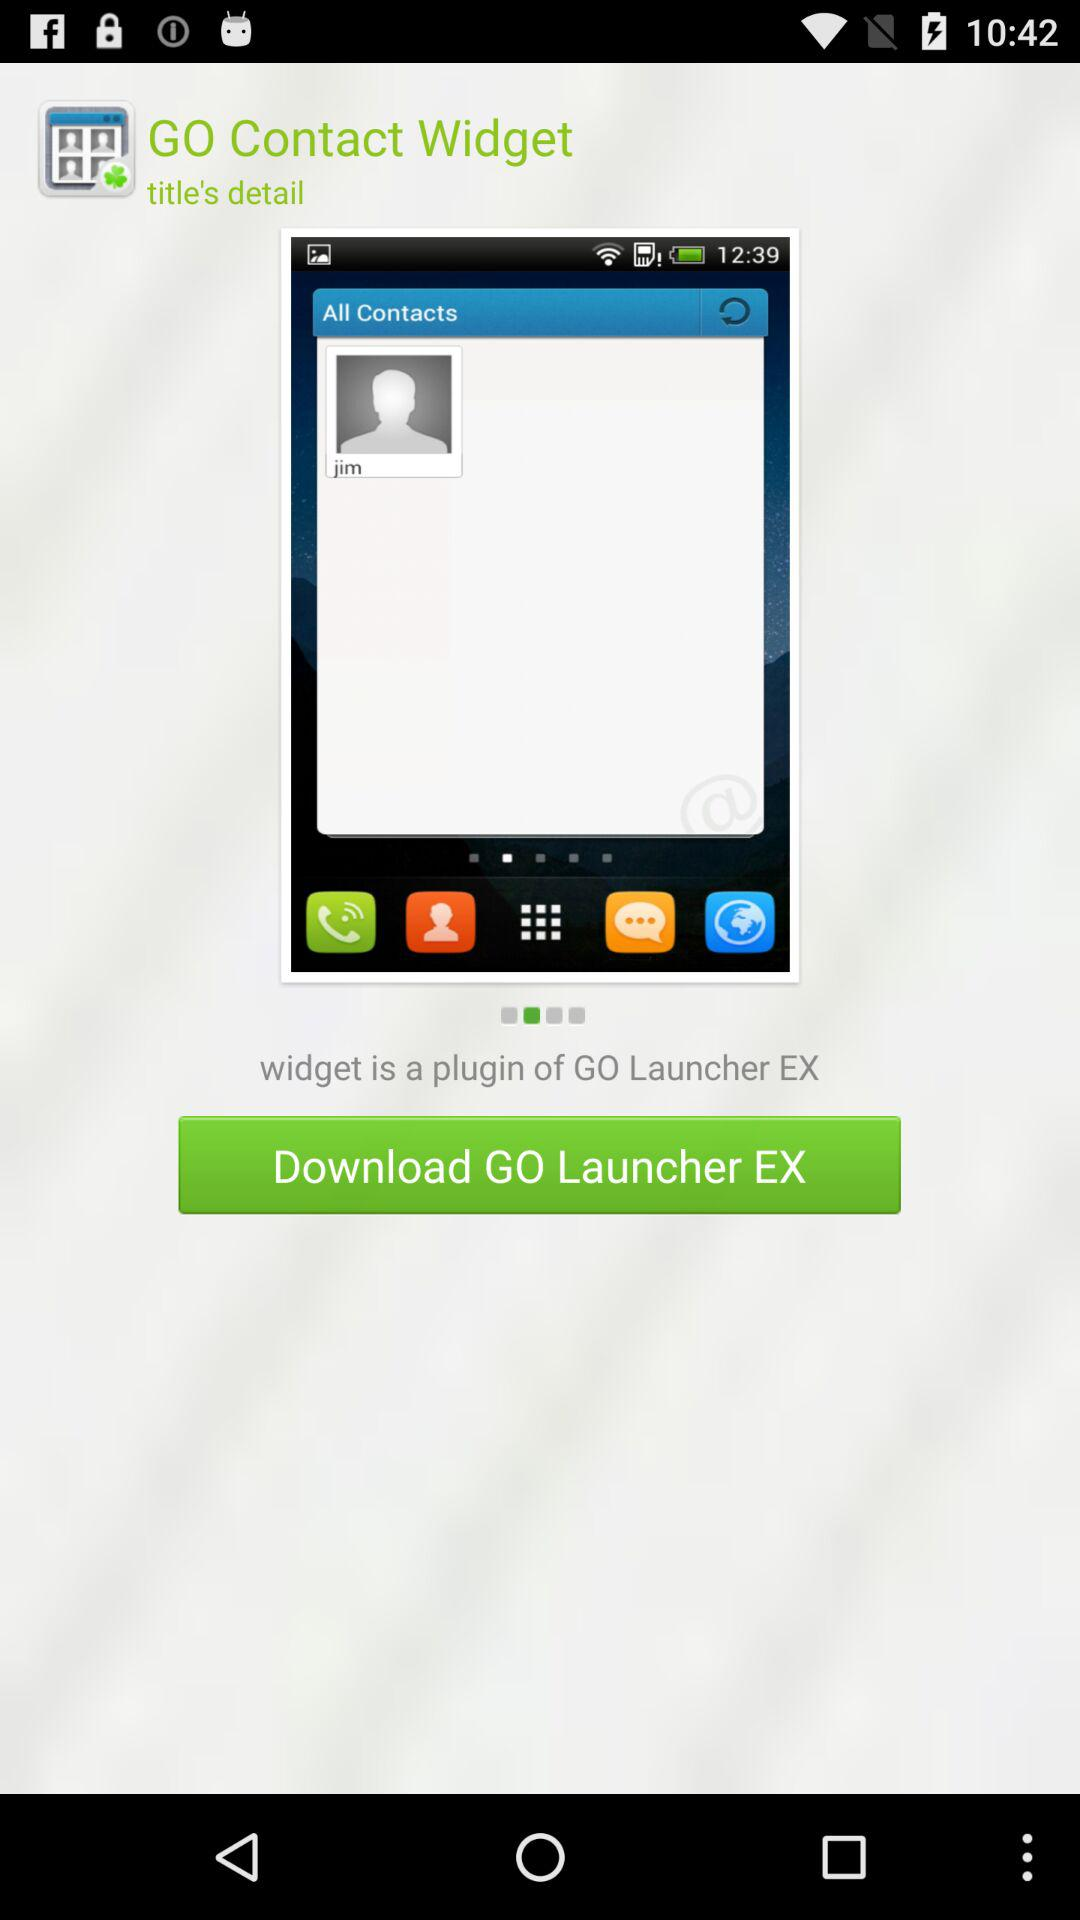What is the name of the application? The name of the application is "GO Contact Widget". 